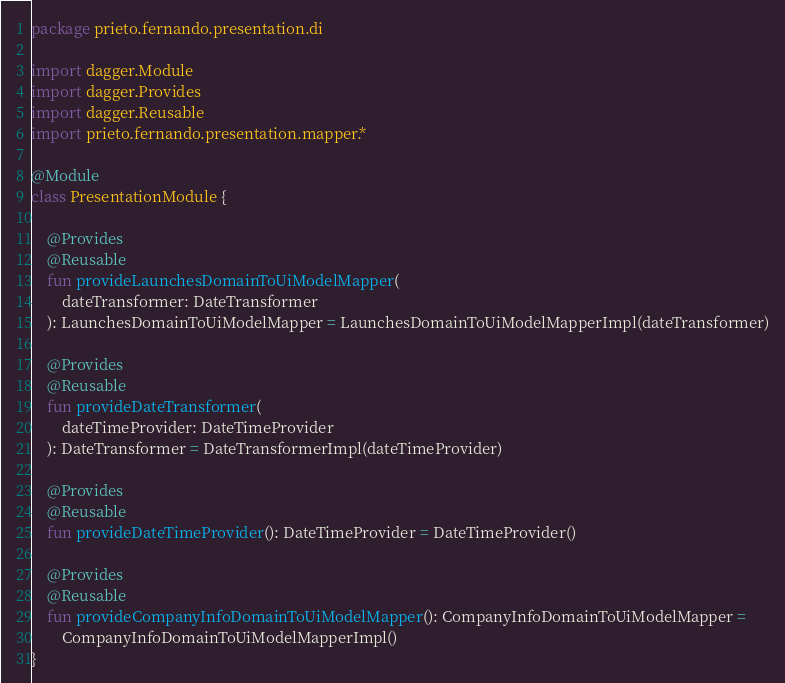<code> <loc_0><loc_0><loc_500><loc_500><_Kotlin_>package prieto.fernando.presentation.di

import dagger.Module
import dagger.Provides
import dagger.Reusable
import prieto.fernando.presentation.mapper.*

@Module
class PresentationModule {

    @Provides
    @Reusable
    fun provideLaunchesDomainToUiModelMapper(
        dateTransformer: DateTransformer
    ): LaunchesDomainToUiModelMapper = LaunchesDomainToUiModelMapperImpl(dateTransformer)

    @Provides
    @Reusable
    fun provideDateTransformer(
        dateTimeProvider: DateTimeProvider
    ): DateTransformer = DateTransformerImpl(dateTimeProvider)

    @Provides
    @Reusable
    fun provideDateTimeProvider(): DateTimeProvider = DateTimeProvider()

    @Provides
    @Reusable
    fun provideCompanyInfoDomainToUiModelMapper(): CompanyInfoDomainToUiModelMapper =
        CompanyInfoDomainToUiModelMapperImpl()
}</code> 